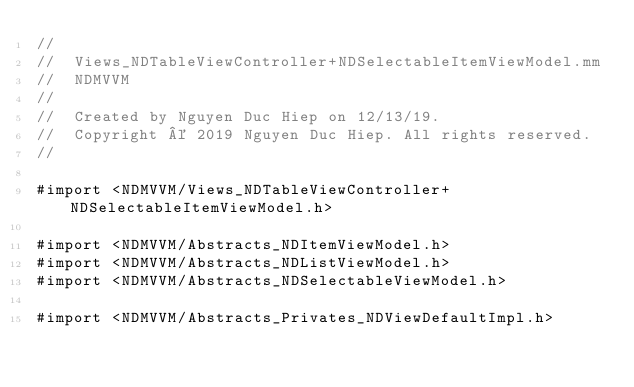Convert code to text. <code><loc_0><loc_0><loc_500><loc_500><_ObjectiveC_>//
//  Views_NDTableViewController+NDSelectableItemViewModel.mm
//  NDMVVM
//
//  Created by Nguyen Duc Hiep on 12/13/19.
//  Copyright © 2019 Nguyen Duc Hiep. All rights reserved.
//

#import <NDMVVM/Views_NDTableViewController+NDSelectableItemViewModel.h>

#import <NDMVVM/Abstracts_NDItemViewModel.h>
#import <NDMVVM/Abstracts_NDListViewModel.h>
#import <NDMVVM/Abstracts_NDSelectableViewModel.h>

#import <NDMVVM/Abstracts_Privates_NDViewDefaultImpl.h>
</code> 